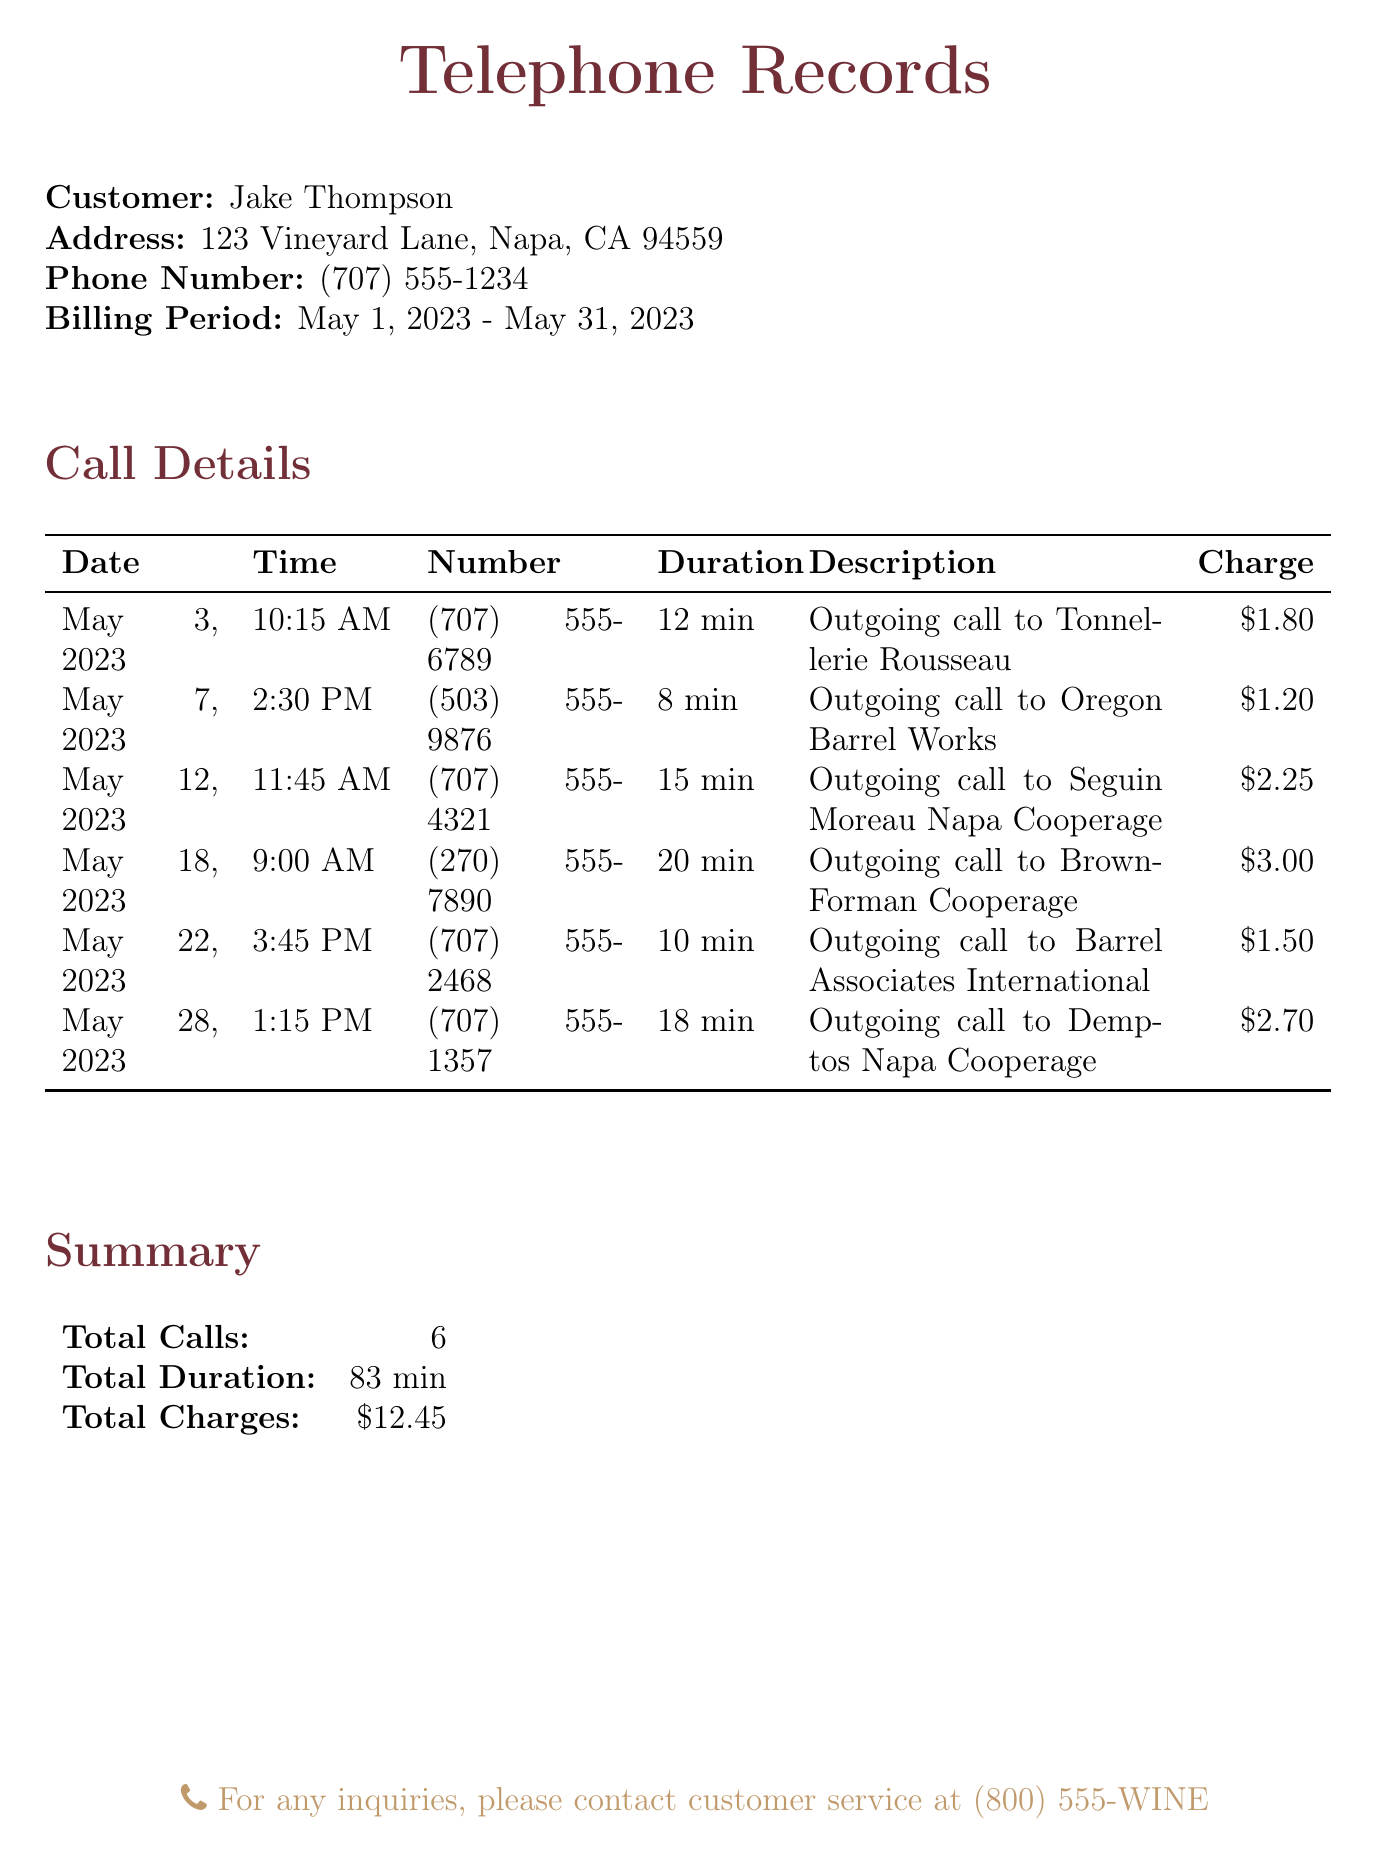What is the customer's name? The customer's name is listed at the top of the document.
Answer: Jake Thompson What is the address of the customer? The address of the customer is provided right below their name.
Answer: 123 Vineyard Lane, Napa, CA 94559 How many calls were made during the billing period? The total number of calls is summarized at the end of the Call Details section.
Answer: 6 What was the longest call duration? The longest call duration can be found by checking the Duration column of the Call Details table.
Answer: 20 min What is the charge for the call to Oregon Barrel Works? The charge for this specific call is indicated in the Charges column next to the corresponding call entry.
Answer: $1.20 Which supplier was called on May 12, 2023? The call description for that date specifies the supplier that was called.
Answer: Seguin Moreau Napa Cooperage What is the total amount charged for all calls? The total charges are provided in the Summary section of the document.
Answer: $12.45 Which call had the highest charge? The charge information in the Call Details allows you to identify the call with the highest charge.
Answer: $3.00 What time was the call to Demptos Napa Cooperage made? The time for this specific call is recorded in the Call Details table.
Answer: 1:15 PM 